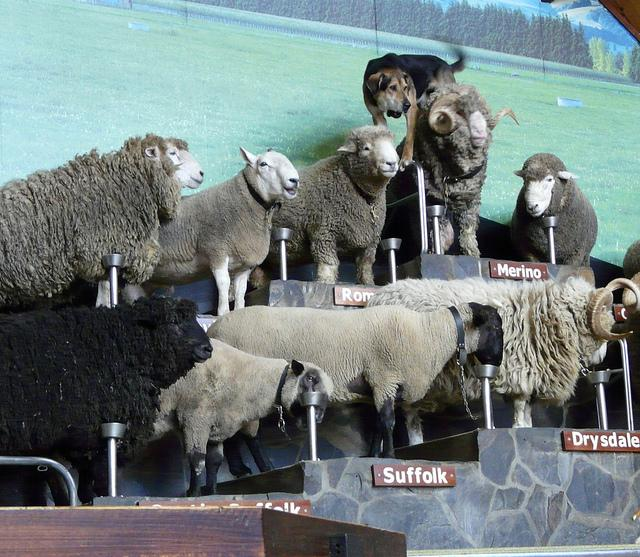What is at the top of the sheep pile? dog 